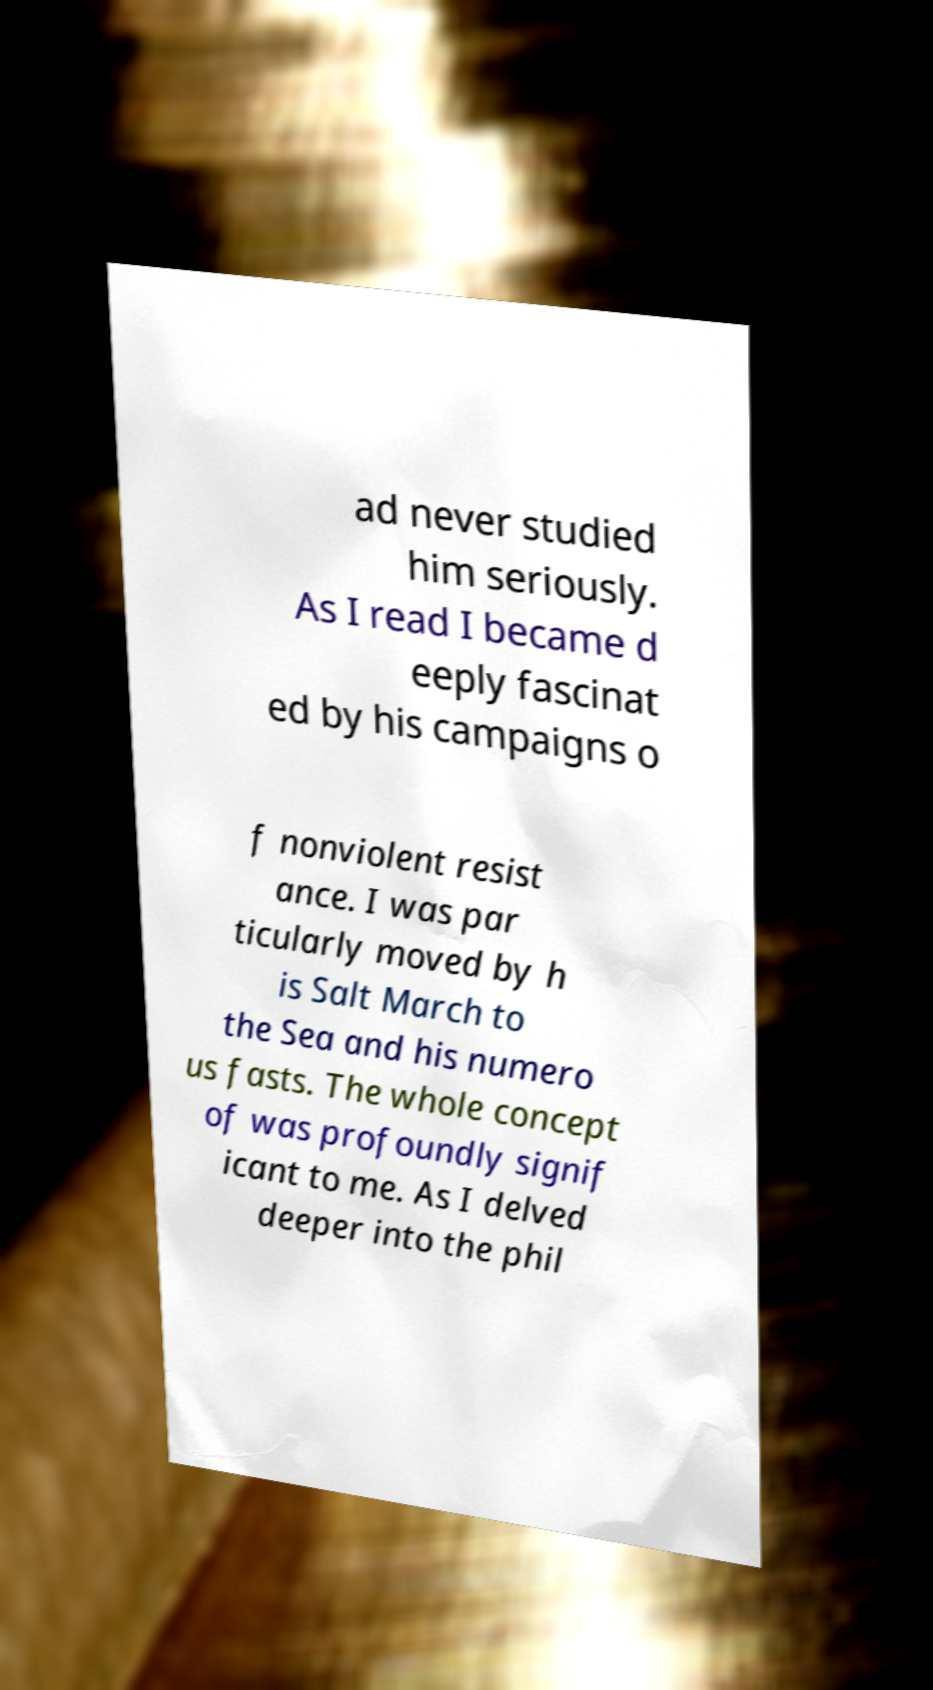Can you read and provide the text displayed in the image?This photo seems to have some interesting text. Can you extract and type it out for me? ad never studied him seriously. As I read I became d eeply fascinat ed by his campaigns o f nonviolent resist ance. I was par ticularly moved by h is Salt March to the Sea and his numero us fasts. The whole concept of was profoundly signif icant to me. As I delved deeper into the phil 